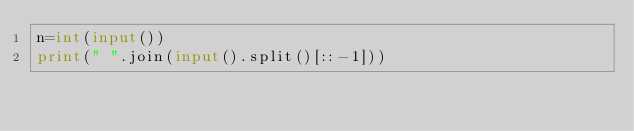Convert code to text. <code><loc_0><loc_0><loc_500><loc_500><_Python_>n=int(input())
print(" ".join(input().split()[::-1]))
</code> 